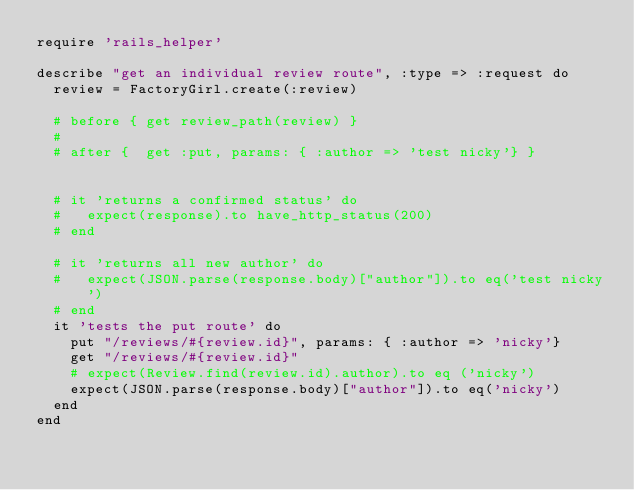<code> <loc_0><loc_0><loc_500><loc_500><_Ruby_>require 'rails_helper'

describe "get an individual review route", :type => :request do
  review = FactoryGirl.create(:review)

  # before { get review_path(review) }
  #
  # after {  get :put, params: { :author => 'test nicky'} }


  # it 'returns a confirmed status' do
  #   expect(response).to have_http_status(200)
  # end

  # it 'returns all new author' do
  #   expect(JSON.parse(response.body)["author"]).to eq('test nicky')
  # end
  it 'tests the put route' do
    put "/reviews/#{review.id}", params: { :author => 'nicky'}
    get "/reviews/#{review.id}"
    # expect(Review.find(review.id).author).to eq ('nicky')
    expect(JSON.parse(response.body)["author"]).to eq('nicky')
  end
end
</code> 